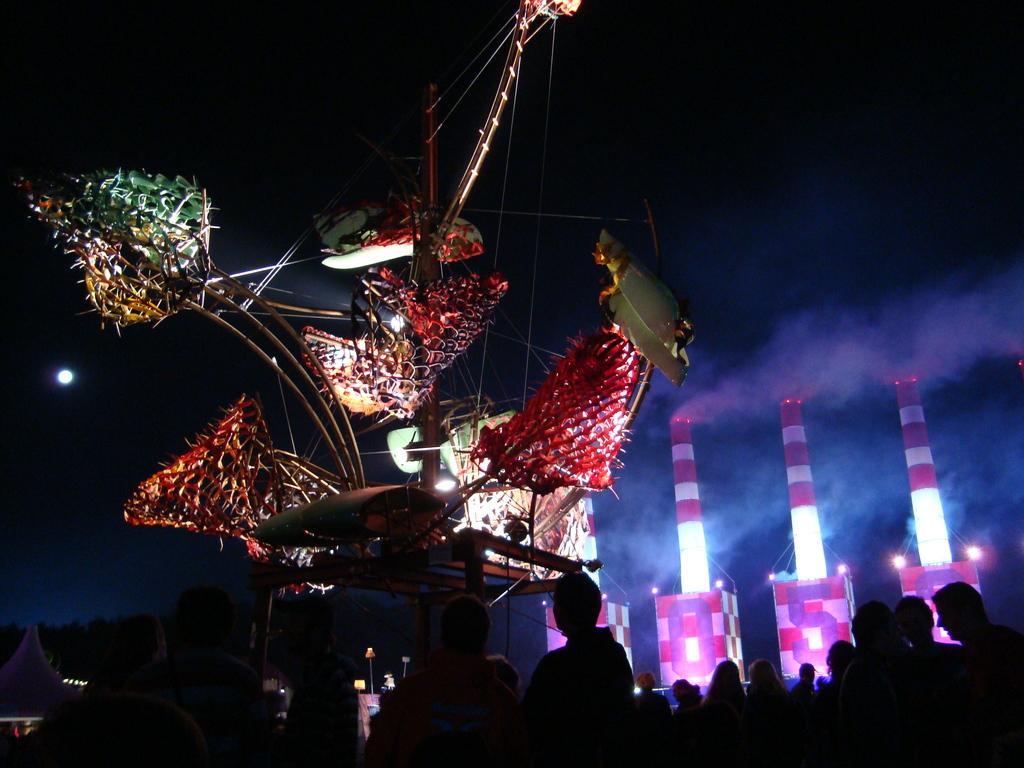How would you summarize this image in a sentence or two? In this image we can see a decorative item. On the right side, we can see three objects look like pillars and smoke. At the bottom we can see a group of persons. On the left side, we can see the moon. The background of the image is dark. 